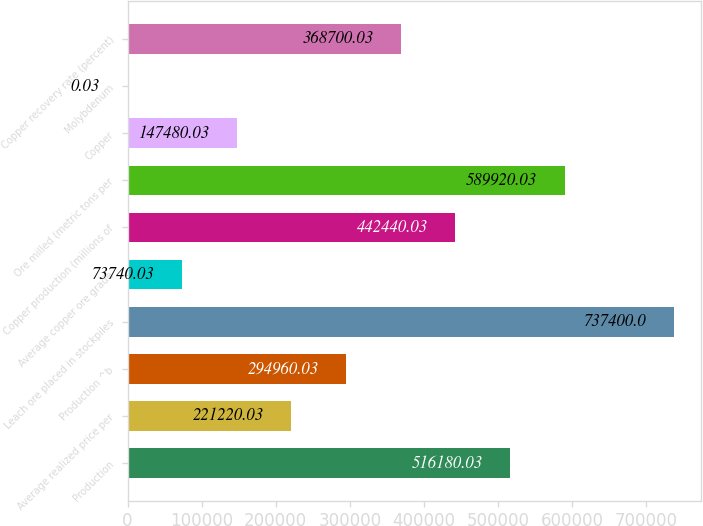Convert chart. <chart><loc_0><loc_0><loc_500><loc_500><bar_chart><fcel>Production<fcel>Average realized price per<fcel>Production ^b<fcel>Leach ore placed in stockpiles<fcel>Average copper ore grade<fcel>Copper production (millions of<fcel>Ore milled (metric tons per<fcel>Copper<fcel>Molybdenum<fcel>Copper recovery rate (percent)<nl><fcel>516180<fcel>221220<fcel>294960<fcel>737400<fcel>73740<fcel>442440<fcel>589920<fcel>147480<fcel>0.03<fcel>368700<nl></chart> 